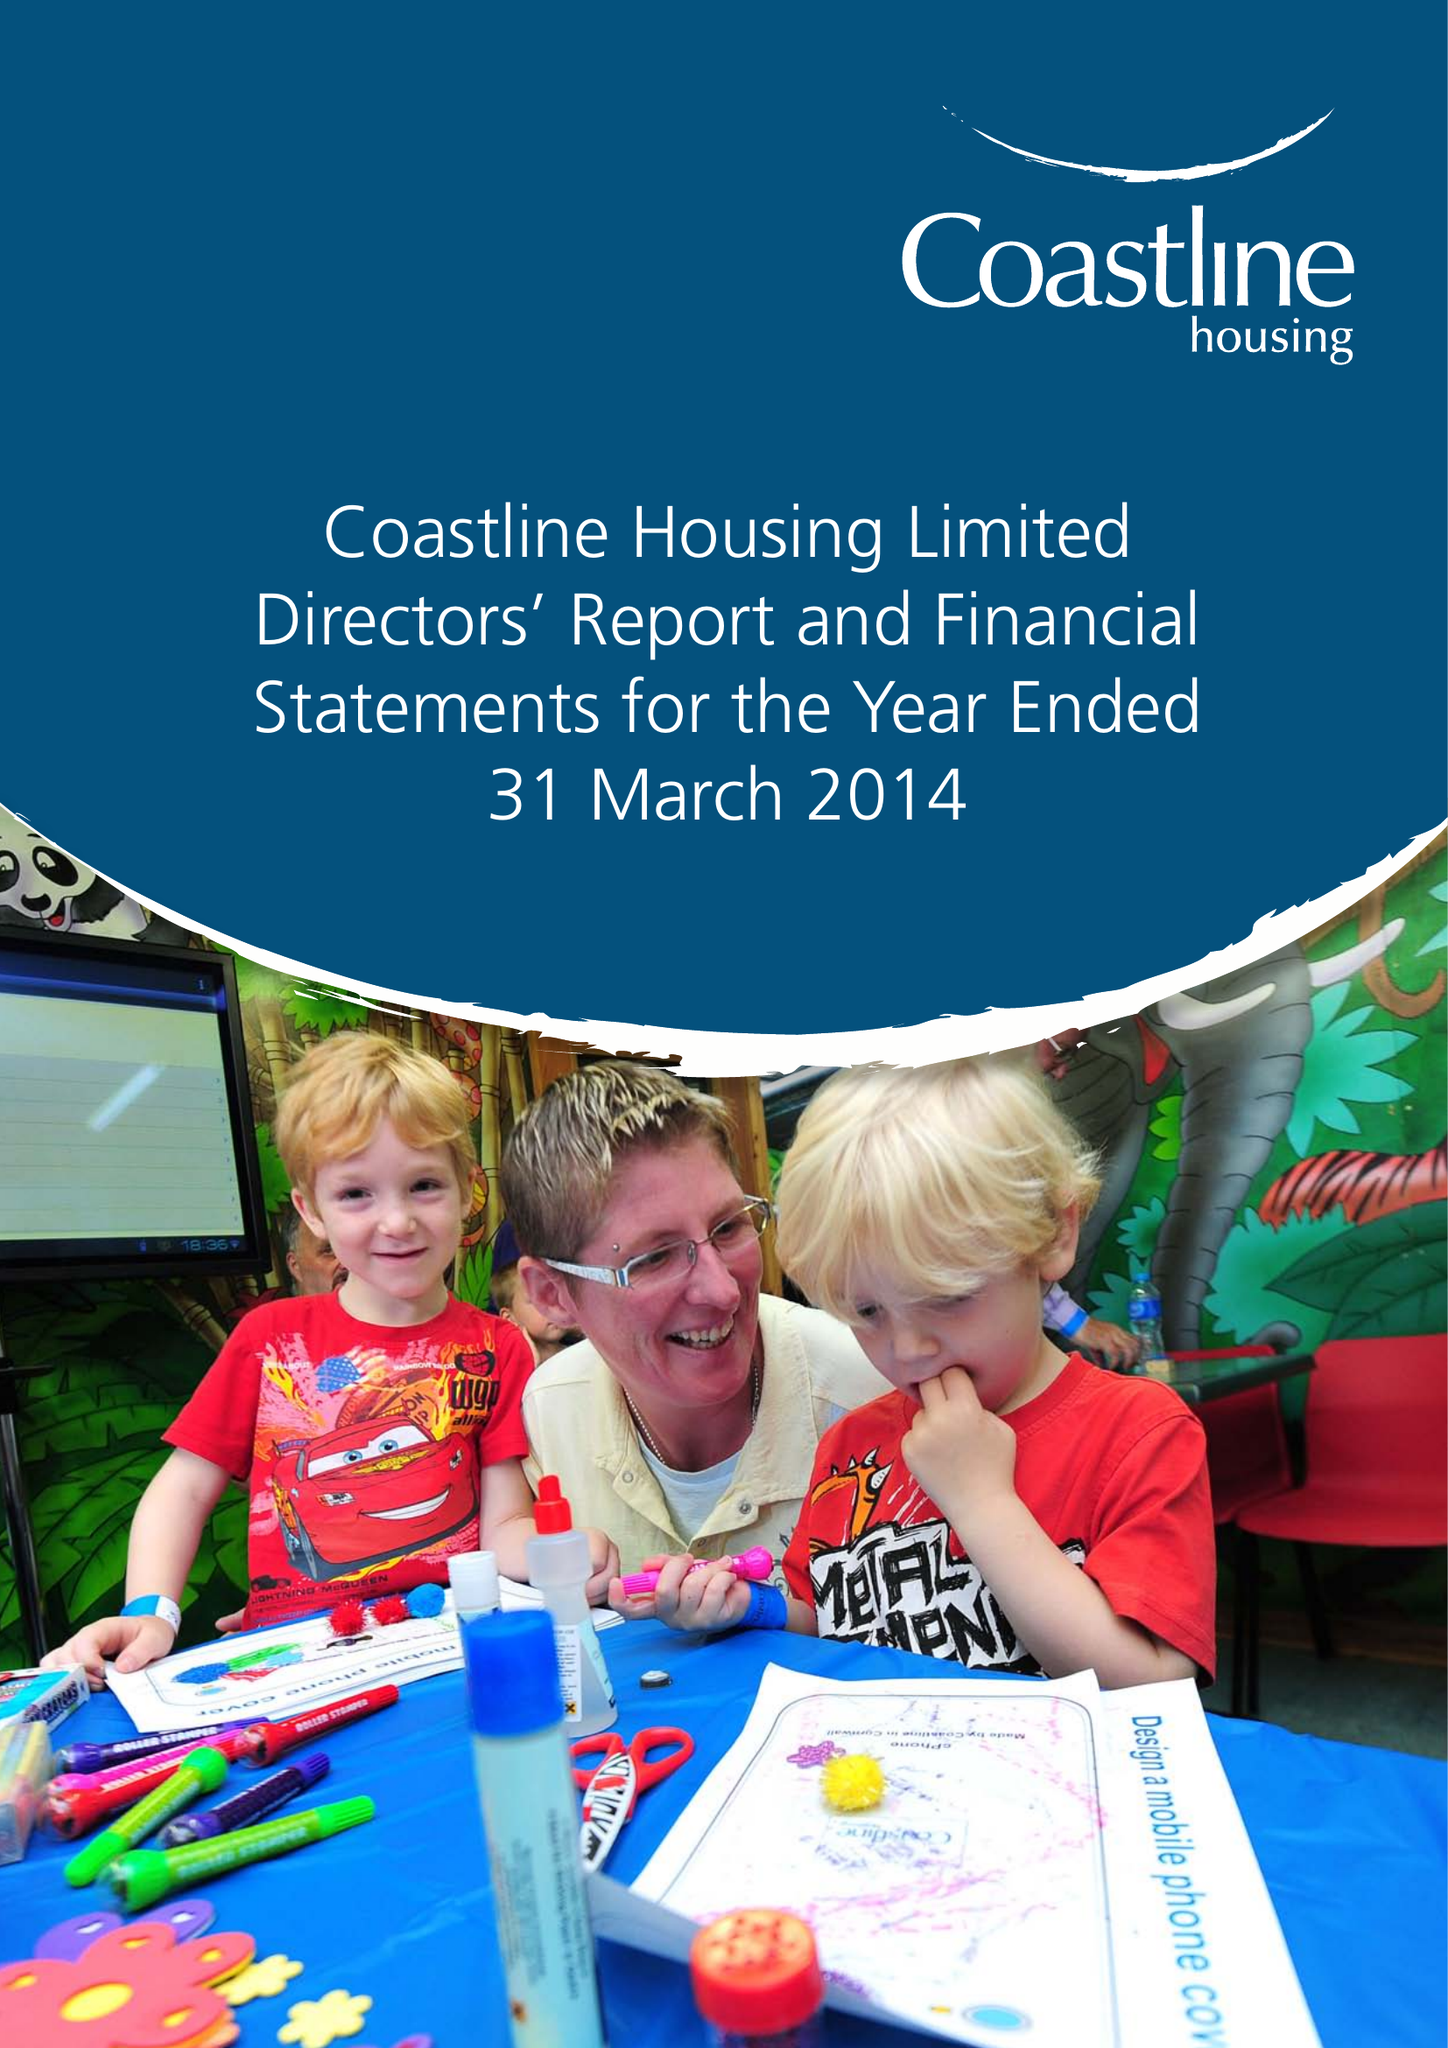What is the value for the address__postcode?
Answer the question using a single word or phrase. TR15 3RQ 